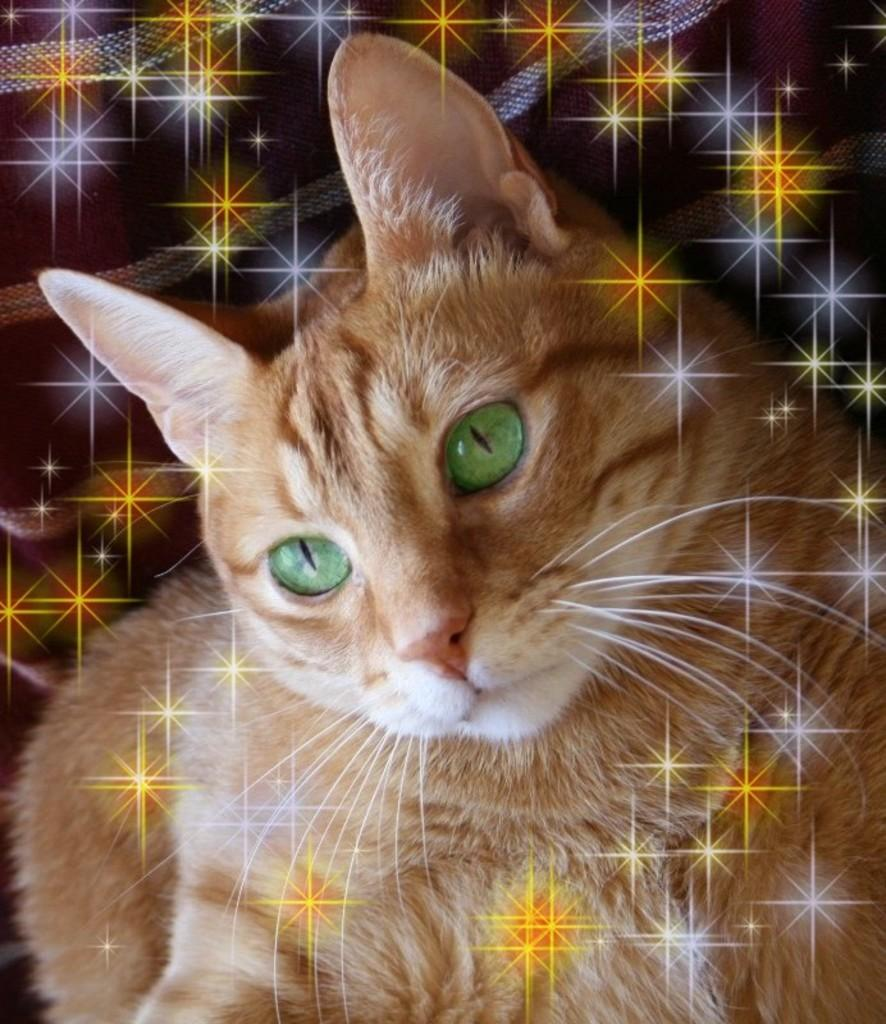What type of animal is in the image? There is a cat in the image. Can you describe the appearance of the cat? The cat is cream-colored. What type of rake is the cat using in the image? There is no rake present in the image, and the cat is not using any tools. 